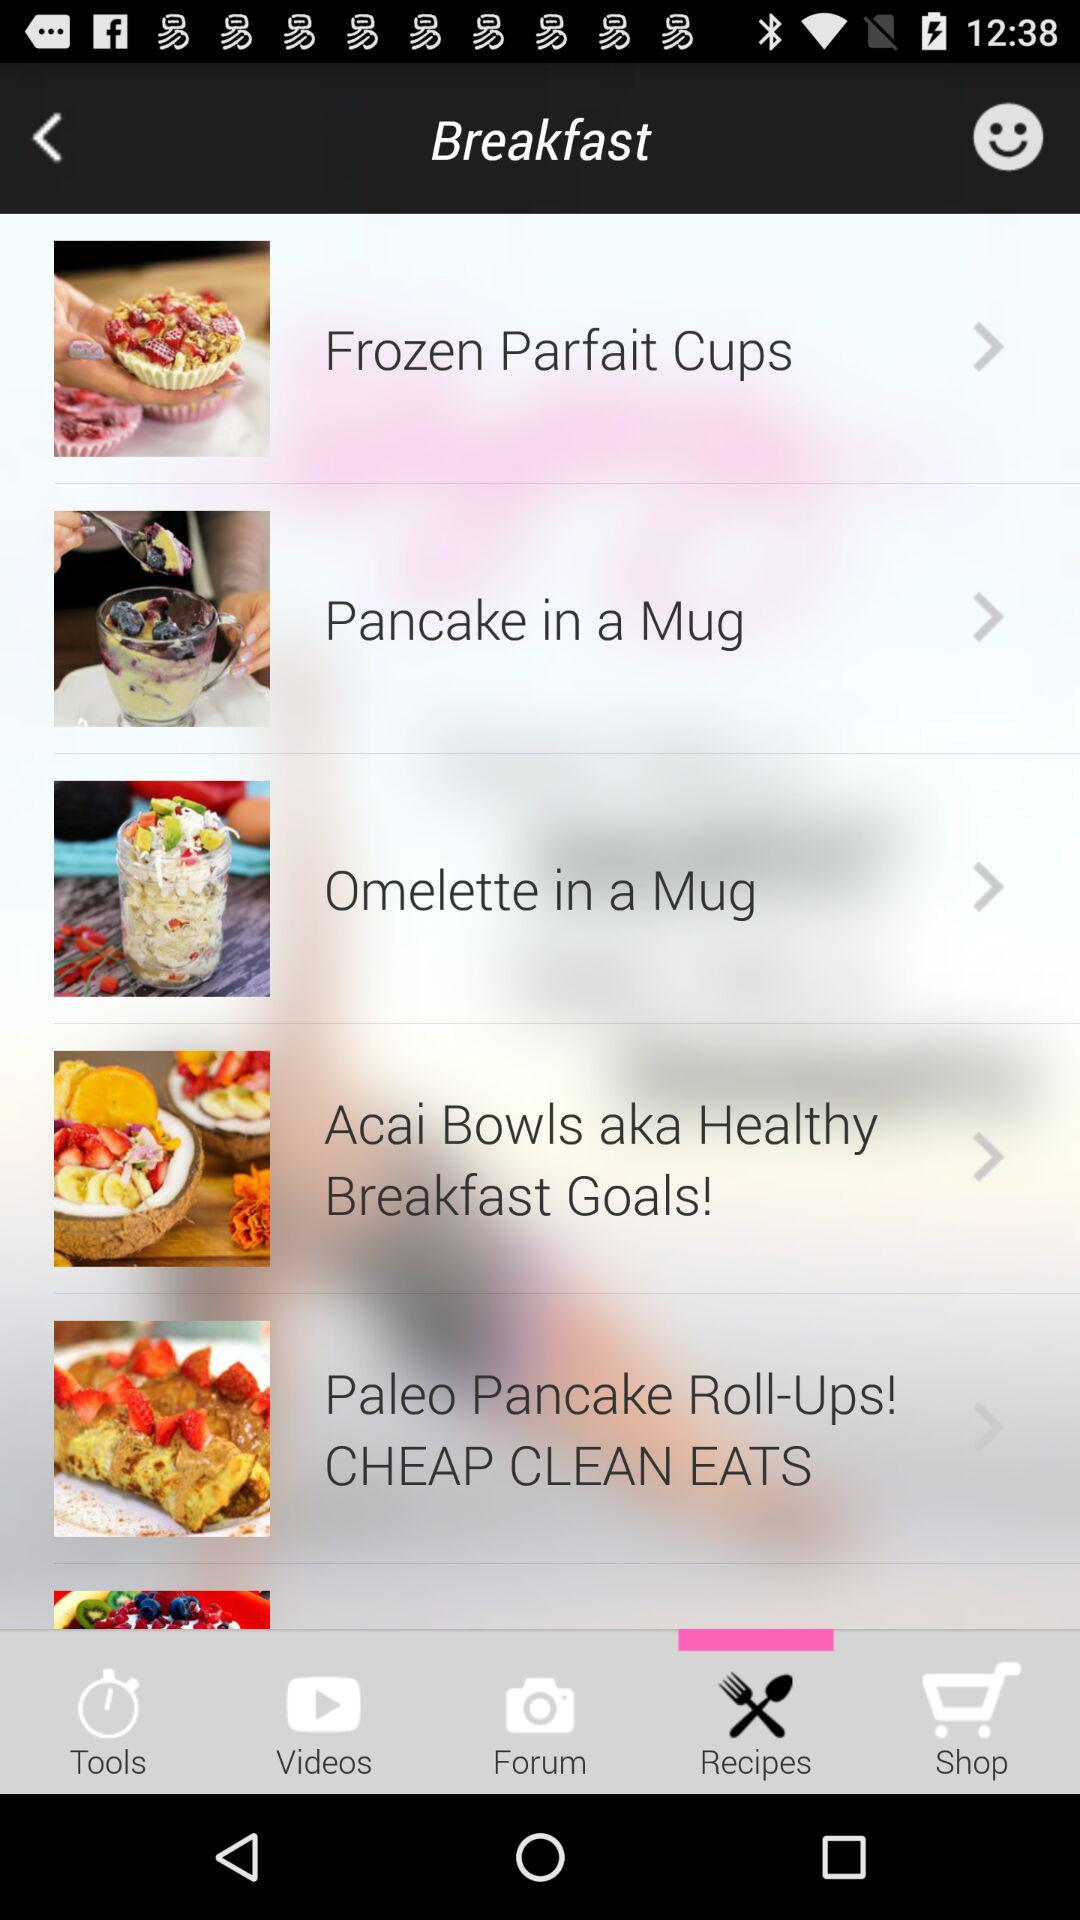Which tab is selected?
Answer the question using a single word or phrase. The selected tab is "Recipes" 